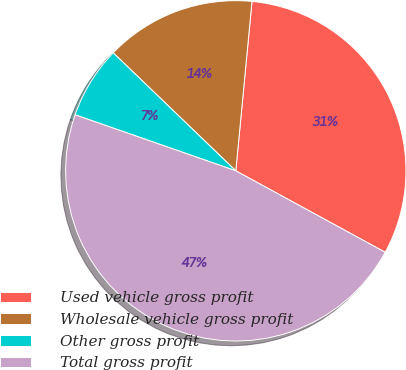<chart> <loc_0><loc_0><loc_500><loc_500><pie_chart><fcel>Used vehicle gross profit<fcel>Wholesale vehicle gross profit<fcel>Other gross profit<fcel>Total gross profit<nl><fcel>31.43%<fcel>14.32%<fcel>6.86%<fcel>47.39%<nl></chart> 